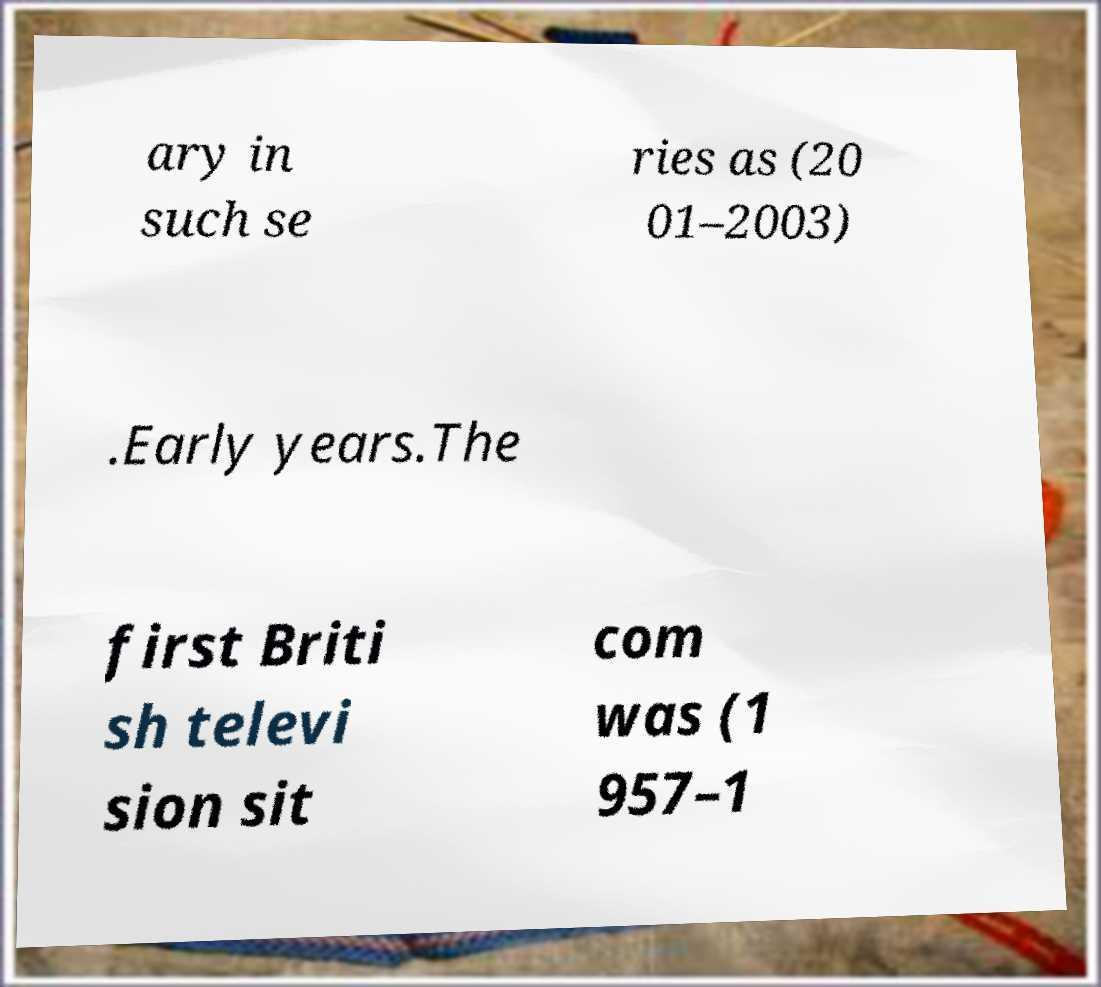Can you read and provide the text displayed in the image?This photo seems to have some interesting text. Can you extract and type it out for me? ary in such se ries as (20 01–2003) .Early years.The first Briti sh televi sion sit com was (1 957–1 